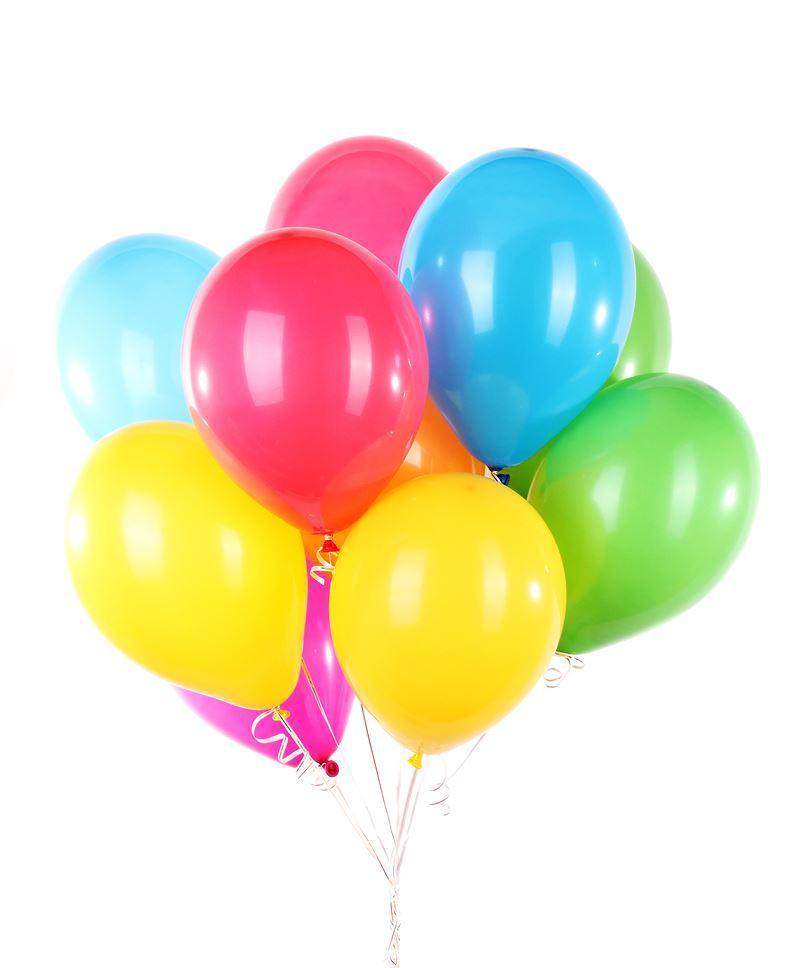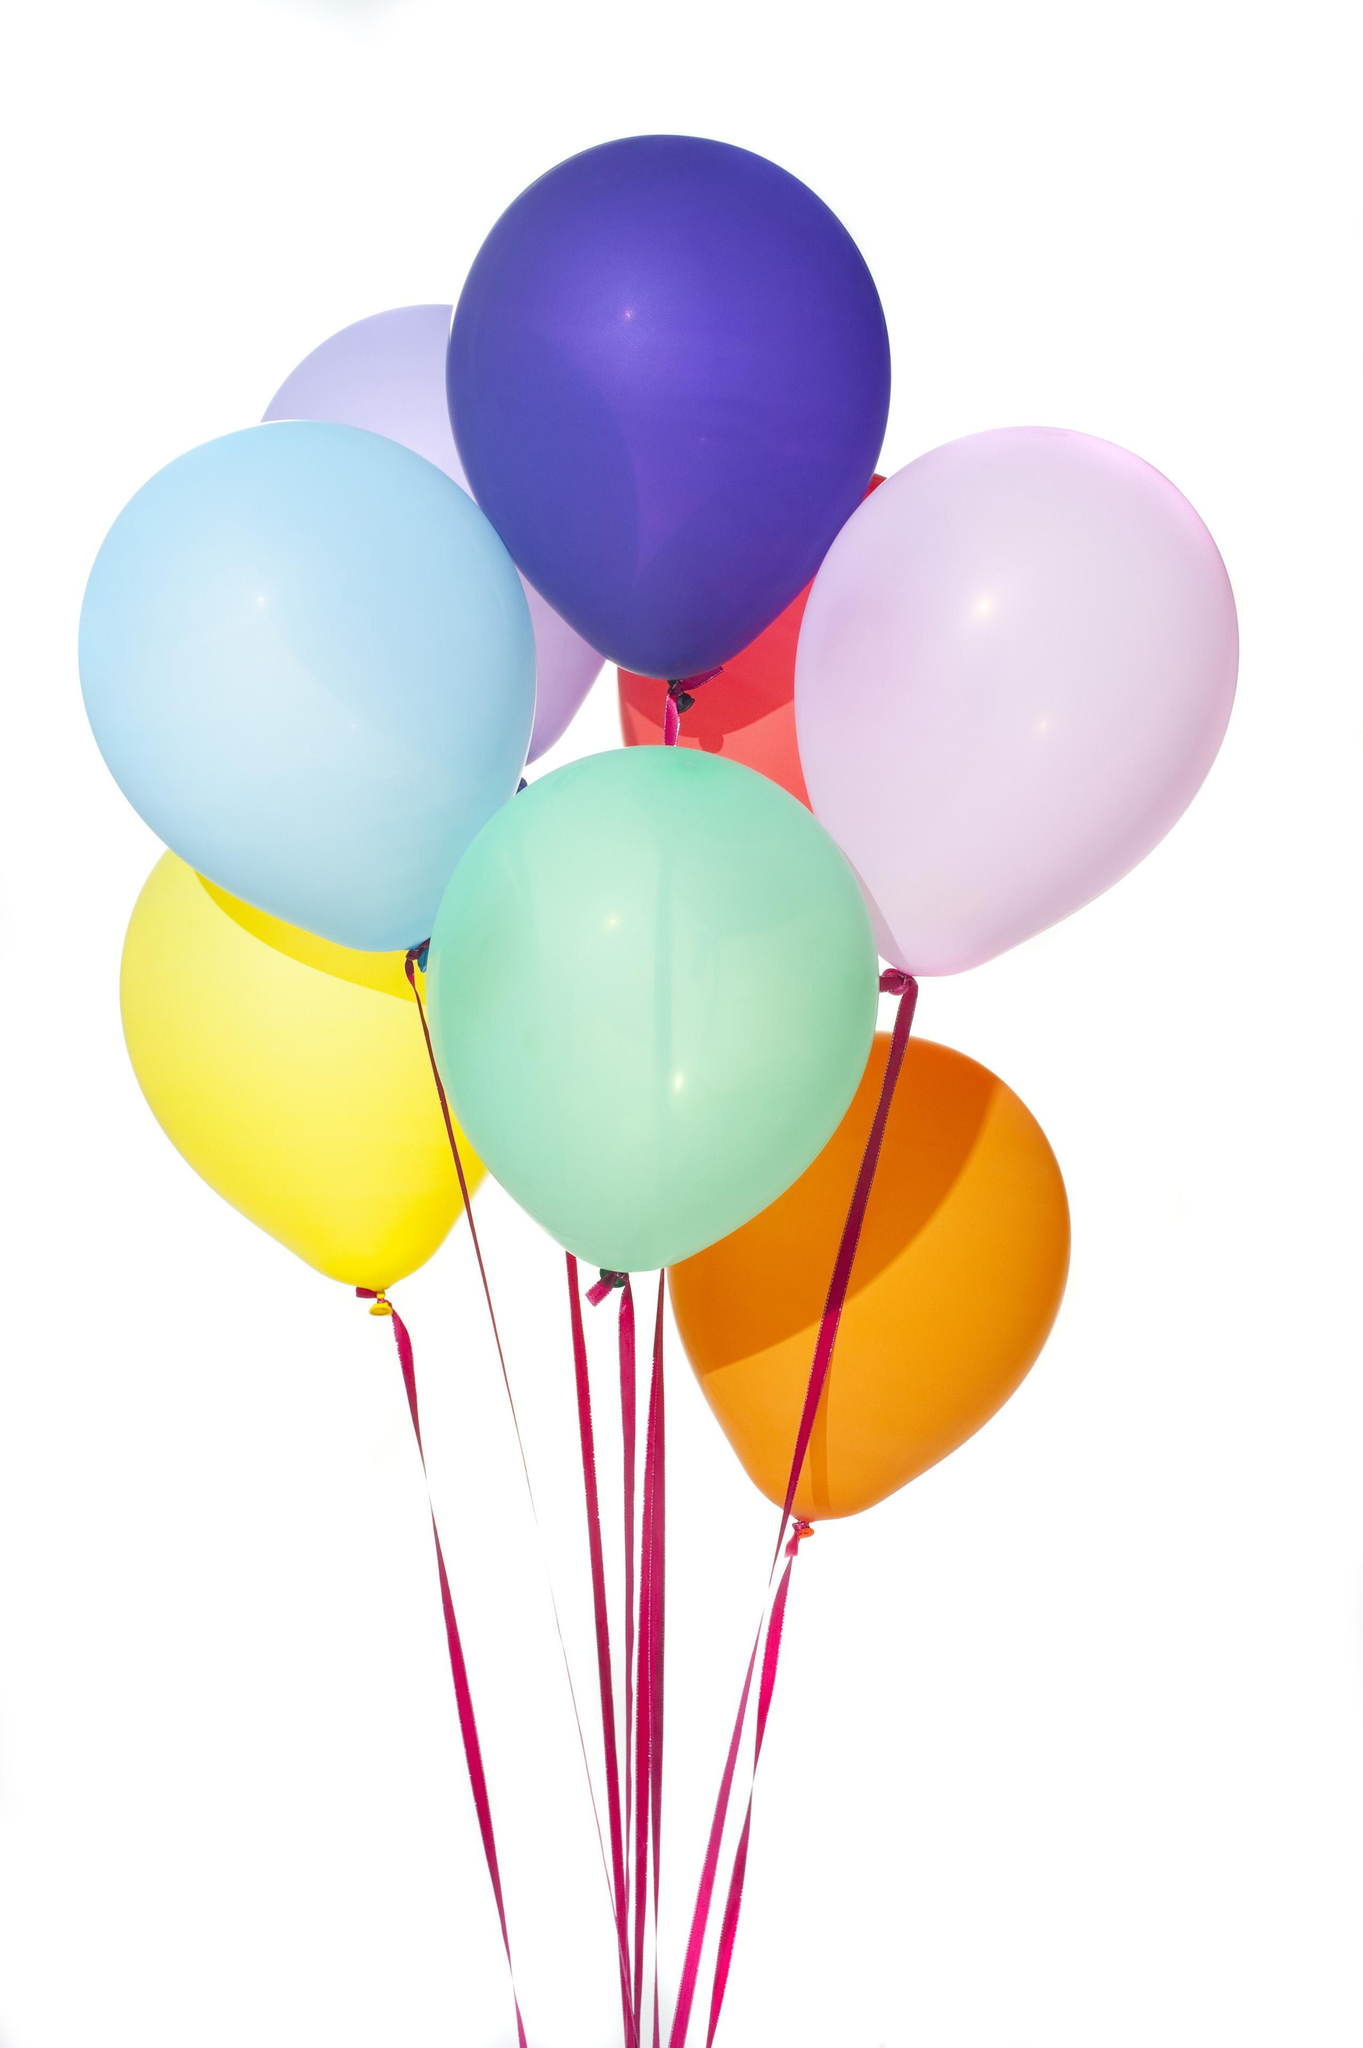The first image is the image on the left, the second image is the image on the right. Analyze the images presented: Is the assertion "Each image shows one bunch of different colored balloons with strings hanging down, and no bunch contains more than 10 balloons." valid? Answer yes or no. Yes. 